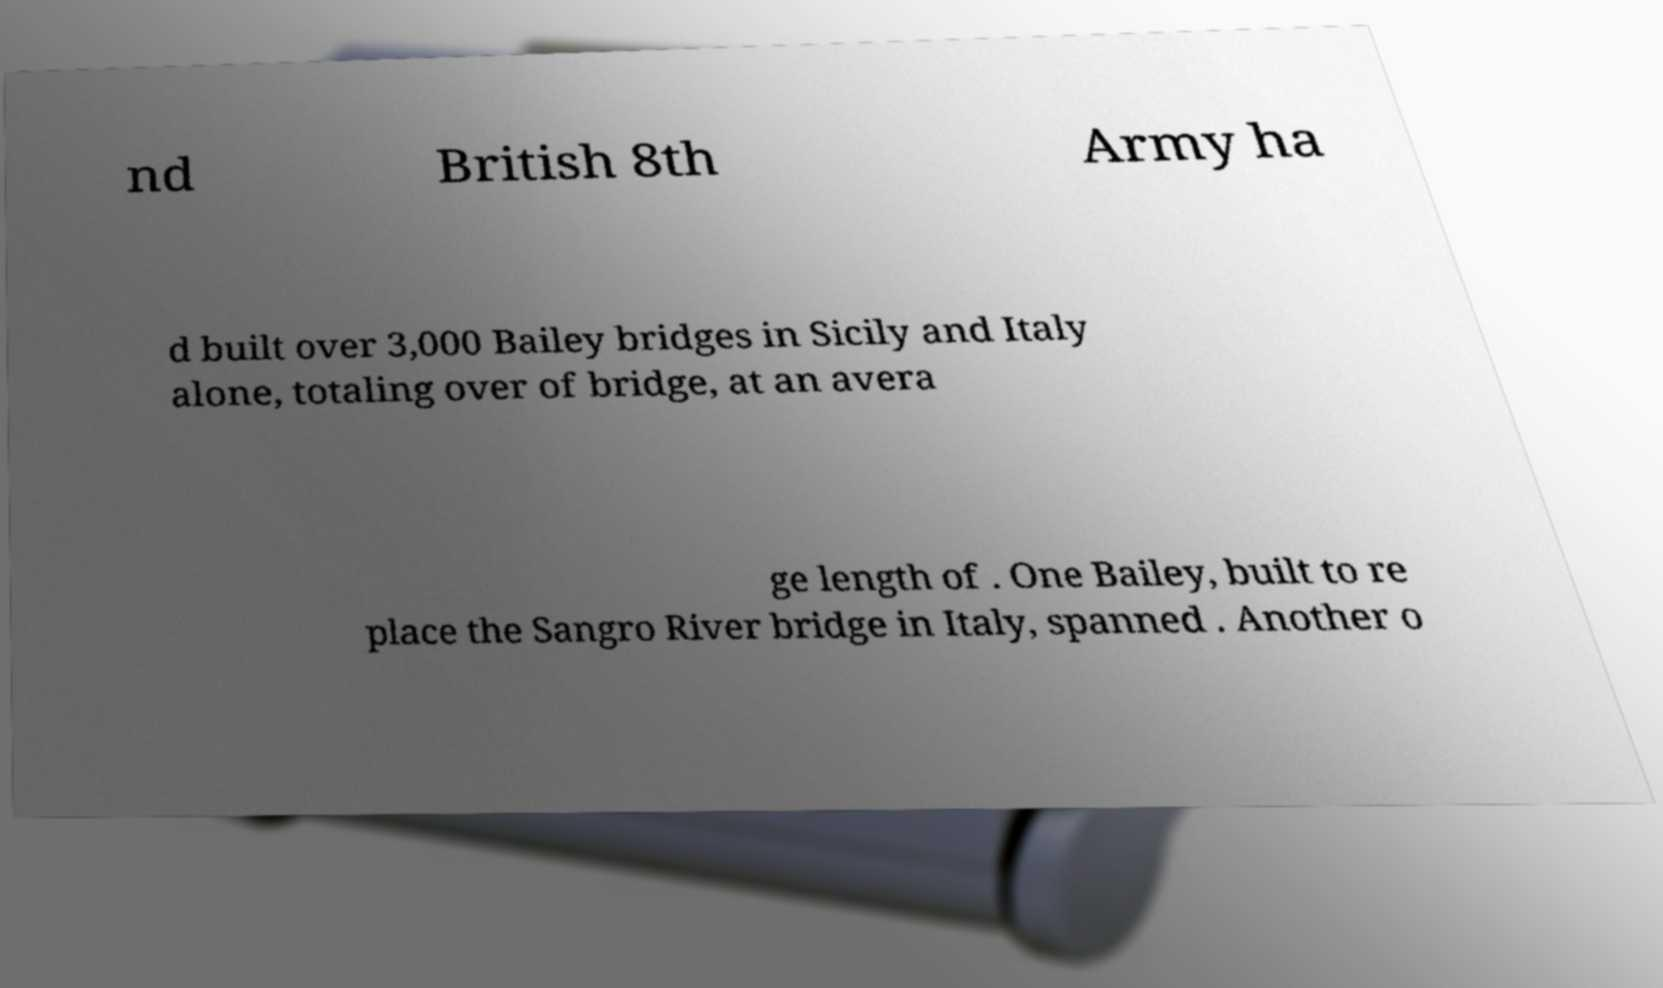Please read and relay the text visible in this image. What does it say? nd British 8th Army ha d built over 3,000 Bailey bridges in Sicily and Italy alone, totaling over of bridge, at an avera ge length of . One Bailey, built to re place the Sangro River bridge in Italy, spanned . Another o 